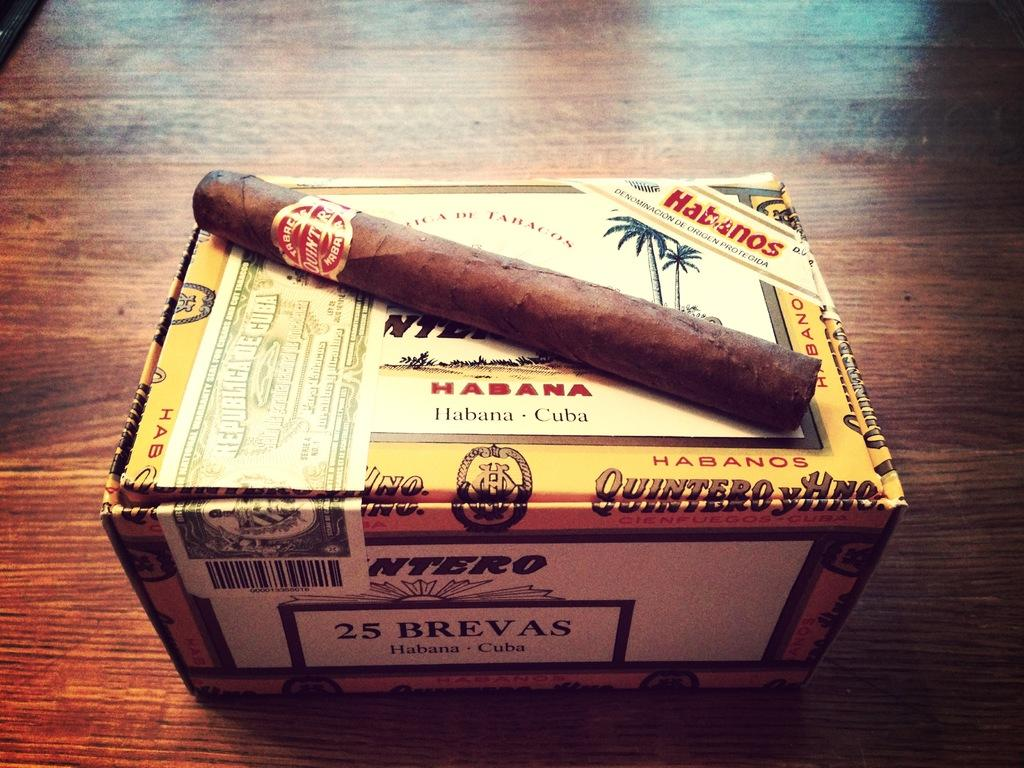<image>
Share a concise interpretation of the image provided. The cigar box is labeled as 25 Brevas 